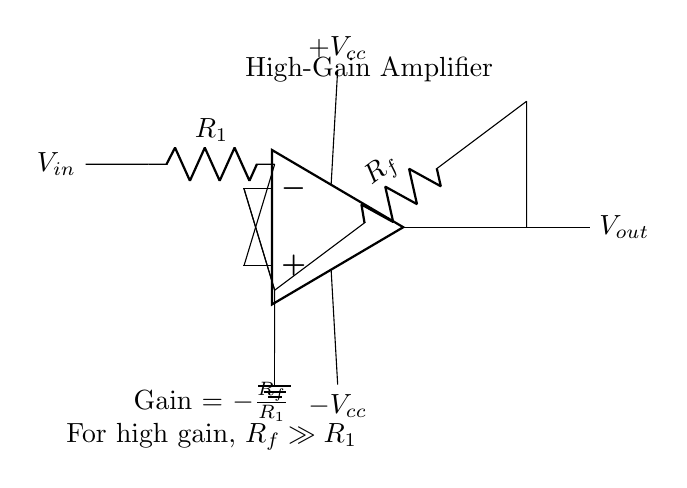What type of amplifier is shown? The diagram shows a high-gain operational amplifier circuit, indicating that it is designed for amplification of low-level signals.
Answer: high-gain operational amplifier What does R1 represent in the circuit? R1 is a resistor placed in series with the input voltage, determining the input signal's influence on the overall gain of the amplifier.
Answer: input resistor What is the relationship between Rf and R1 for high gain? The gain formula indicates that for high gain, Rf must be much larger than R1; this condition enhances the overall amplification factor.
Answer: Rf >> R1 What is the output voltage Vout determined by? Vout is determined by the input voltage Vin, the feedback resistor Rf, and the input resistor R1 according to the gain formula Gain = -Rf/R1.
Answer: gain formula What is the gain formula for this amplifier circuit? The gain is expressed as Gain = -Rf/R1, demonstrating how the feedback resistance and input resistance interact to define the amplification level.
Answer: Gain = -Rf/R1 Which terminals of the op-amp are used for input? The positive terminal (non-inverting) and the negative terminal (inverting) of the operational amplifier are used, with the input voltage connected to the positive terminal.
Answer: positive and negative terminals How is power supplied to the op-amp? The power is supplied with dual voltage sources: one to the positive terminal labeled +Vcc and another to the negative terminal labeled -Vcc.
Answer: dual power supply 